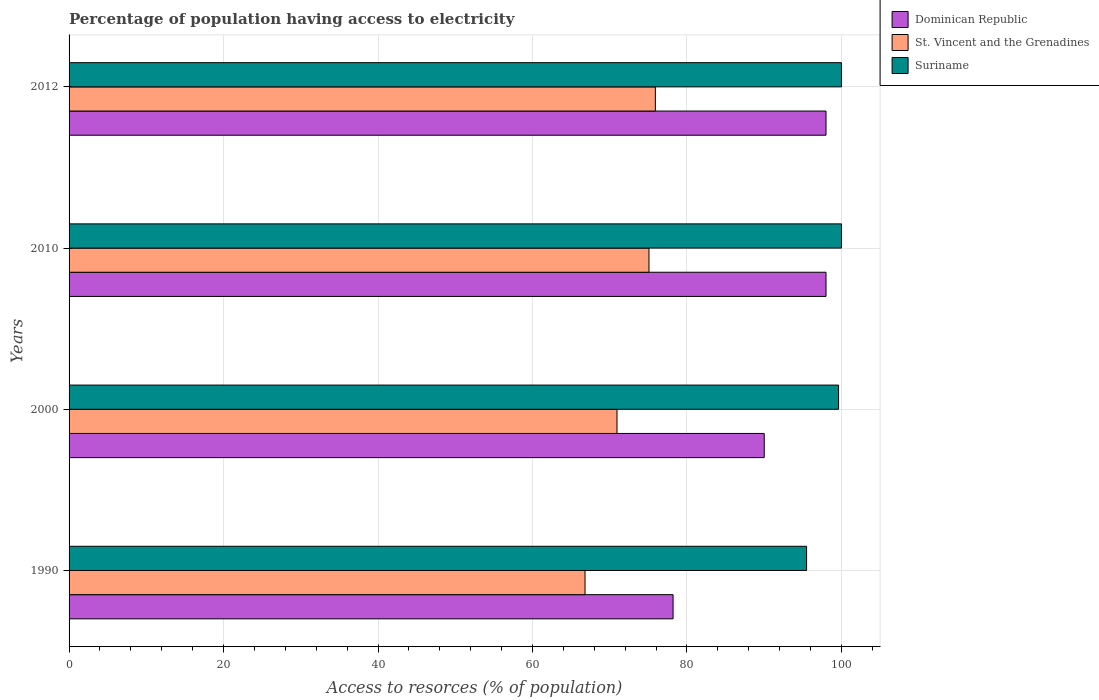How many groups of bars are there?
Provide a succinct answer. 4. How many bars are there on the 4th tick from the bottom?
Provide a short and direct response. 3. What is the percentage of population having access to electricity in St. Vincent and the Grenadines in 2000?
Offer a very short reply. 70.94. Across all years, what is the maximum percentage of population having access to electricity in St. Vincent and the Grenadines?
Ensure brevity in your answer.  75.91. Across all years, what is the minimum percentage of population having access to electricity in Suriname?
Ensure brevity in your answer.  95.49. In which year was the percentage of population having access to electricity in Dominican Republic maximum?
Keep it short and to the point. 2010. In which year was the percentage of population having access to electricity in St. Vincent and the Grenadines minimum?
Provide a short and direct response. 1990. What is the total percentage of population having access to electricity in St. Vincent and the Grenadines in the graph?
Provide a short and direct response. 288.72. What is the difference between the percentage of population having access to electricity in Dominican Republic in 1990 and that in 2010?
Offer a very short reply. -19.8. What is the difference between the percentage of population having access to electricity in Dominican Republic in 2010 and the percentage of population having access to electricity in Suriname in 2000?
Offer a very short reply. -1.62. What is the average percentage of population having access to electricity in Dominican Republic per year?
Your response must be concise. 91.05. In the year 2000, what is the difference between the percentage of population having access to electricity in Suriname and percentage of population having access to electricity in Dominican Republic?
Keep it short and to the point. 9.62. In how many years, is the percentage of population having access to electricity in St. Vincent and the Grenadines greater than 40 %?
Provide a succinct answer. 4. What is the ratio of the percentage of population having access to electricity in Suriname in 1990 to that in 2012?
Your response must be concise. 0.95. Is the percentage of population having access to electricity in St. Vincent and the Grenadines in 1990 less than that in 2012?
Your answer should be compact. Yes. What is the difference between the highest and the second highest percentage of population having access to electricity in St. Vincent and the Grenadines?
Offer a very short reply. 0.83. What is the difference between the highest and the lowest percentage of population having access to electricity in Suriname?
Offer a very short reply. 4.51. In how many years, is the percentage of population having access to electricity in St. Vincent and the Grenadines greater than the average percentage of population having access to electricity in St. Vincent and the Grenadines taken over all years?
Your answer should be compact. 2. Is the sum of the percentage of population having access to electricity in Dominican Republic in 1990 and 2012 greater than the maximum percentage of population having access to electricity in Suriname across all years?
Your answer should be very brief. Yes. What does the 3rd bar from the top in 1990 represents?
Offer a terse response. Dominican Republic. What does the 3rd bar from the bottom in 2012 represents?
Offer a very short reply. Suriname. Are all the bars in the graph horizontal?
Your response must be concise. Yes. What is the difference between two consecutive major ticks on the X-axis?
Provide a short and direct response. 20. Does the graph contain any zero values?
Give a very brief answer. No. What is the title of the graph?
Keep it short and to the point. Percentage of population having access to electricity. Does "Italy" appear as one of the legend labels in the graph?
Your answer should be very brief. No. What is the label or title of the X-axis?
Your response must be concise. Access to resorces (% of population). What is the Access to resorces (% of population) of Dominican Republic in 1990?
Your response must be concise. 78.2. What is the Access to resorces (% of population) of St. Vincent and the Grenadines in 1990?
Make the answer very short. 66.8. What is the Access to resorces (% of population) of Suriname in 1990?
Make the answer very short. 95.49. What is the Access to resorces (% of population) in St. Vincent and the Grenadines in 2000?
Your response must be concise. 70.94. What is the Access to resorces (% of population) in Suriname in 2000?
Ensure brevity in your answer.  99.62. What is the Access to resorces (% of population) in Dominican Republic in 2010?
Your response must be concise. 98. What is the Access to resorces (% of population) of St. Vincent and the Grenadines in 2010?
Provide a succinct answer. 75.08. What is the Access to resorces (% of population) of Suriname in 2010?
Make the answer very short. 100. What is the Access to resorces (% of population) in St. Vincent and the Grenadines in 2012?
Ensure brevity in your answer.  75.91. What is the Access to resorces (% of population) of Suriname in 2012?
Provide a short and direct response. 100. Across all years, what is the maximum Access to resorces (% of population) in Dominican Republic?
Offer a terse response. 98. Across all years, what is the maximum Access to resorces (% of population) of St. Vincent and the Grenadines?
Make the answer very short. 75.91. Across all years, what is the minimum Access to resorces (% of population) of Dominican Republic?
Ensure brevity in your answer.  78.2. Across all years, what is the minimum Access to resorces (% of population) in St. Vincent and the Grenadines?
Your answer should be very brief. 66.8. Across all years, what is the minimum Access to resorces (% of population) in Suriname?
Keep it short and to the point. 95.49. What is the total Access to resorces (% of population) in Dominican Republic in the graph?
Give a very brief answer. 364.2. What is the total Access to resorces (% of population) in St. Vincent and the Grenadines in the graph?
Provide a short and direct response. 288.72. What is the total Access to resorces (% of population) in Suriname in the graph?
Provide a short and direct response. 395.11. What is the difference between the Access to resorces (% of population) in Dominican Republic in 1990 and that in 2000?
Your answer should be very brief. -11.8. What is the difference between the Access to resorces (% of population) in St. Vincent and the Grenadines in 1990 and that in 2000?
Offer a very short reply. -4.14. What is the difference between the Access to resorces (% of population) of Suriname in 1990 and that in 2000?
Keep it short and to the point. -4.14. What is the difference between the Access to resorces (% of population) in Dominican Republic in 1990 and that in 2010?
Offer a very short reply. -19.8. What is the difference between the Access to resorces (% of population) of St. Vincent and the Grenadines in 1990 and that in 2010?
Offer a terse response. -8.28. What is the difference between the Access to resorces (% of population) in Suriname in 1990 and that in 2010?
Give a very brief answer. -4.51. What is the difference between the Access to resorces (% of population) of Dominican Republic in 1990 and that in 2012?
Your answer should be very brief. -19.8. What is the difference between the Access to resorces (% of population) in St. Vincent and the Grenadines in 1990 and that in 2012?
Offer a terse response. -9.11. What is the difference between the Access to resorces (% of population) in Suriname in 1990 and that in 2012?
Offer a very short reply. -4.51. What is the difference between the Access to resorces (% of population) in Dominican Republic in 2000 and that in 2010?
Provide a short and direct response. -8. What is the difference between the Access to resorces (% of population) in St. Vincent and the Grenadines in 2000 and that in 2010?
Your answer should be very brief. -4.14. What is the difference between the Access to resorces (% of population) in Suriname in 2000 and that in 2010?
Provide a short and direct response. -0.38. What is the difference between the Access to resorces (% of population) of St. Vincent and the Grenadines in 2000 and that in 2012?
Provide a short and direct response. -4.97. What is the difference between the Access to resorces (% of population) in Suriname in 2000 and that in 2012?
Give a very brief answer. -0.38. What is the difference between the Access to resorces (% of population) of Dominican Republic in 2010 and that in 2012?
Your response must be concise. 0. What is the difference between the Access to resorces (% of population) of St. Vincent and the Grenadines in 2010 and that in 2012?
Ensure brevity in your answer.  -0.83. What is the difference between the Access to resorces (% of population) of Suriname in 2010 and that in 2012?
Your answer should be very brief. 0. What is the difference between the Access to resorces (% of population) in Dominican Republic in 1990 and the Access to resorces (% of population) in St. Vincent and the Grenadines in 2000?
Provide a succinct answer. 7.26. What is the difference between the Access to resorces (% of population) in Dominican Republic in 1990 and the Access to resorces (% of population) in Suriname in 2000?
Offer a terse response. -21.42. What is the difference between the Access to resorces (% of population) in St. Vincent and the Grenadines in 1990 and the Access to resorces (% of population) in Suriname in 2000?
Offer a terse response. -32.82. What is the difference between the Access to resorces (% of population) of Dominican Republic in 1990 and the Access to resorces (% of population) of St. Vincent and the Grenadines in 2010?
Offer a terse response. 3.12. What is the difference between the Access to resorces (% of population) of Dominican Republic in 1990 and the Access to resorces (% of population) of Suriname in 2010?
Provide a short and direct response. -21.8. What is the difference between the Access to resorces (% of population) of St. Vincent and the Grenadines in 1990 and the Access to resorces (% of population) of Suriname in 2010?
Offer a terse response. -33.2. What is the difference between the Access to resorces (% of population) in Dominican Republic in 1990 and the Access to resorces (% of population) in St. Vincent and the Grenadines in 2012?
Give a very brief answer. 2.29. What is the difference between the Access to resorces (% of population) in Dominican Republic in 1990 and the Access to resorces (% of population) in Suriname in 2012?
Provide a short and direct response. -21.8. What is the difference between the Access to resorces (% of population) in St. Vincent and the Grenadines in 1990 and the Access to resorces (% of population) in Suriname in 2012?
Offer a very short reply. -33.2. What is the difference between the Access to resorces (% of population) of Dominican Republic in 2000 and the Access to resorces (% of population) of St. Vincent and the Grenadines in 2010?
Provide a short and direct response. 14.92. What is the difference between the Access to resorces (% of population) in St. Vincent and the Grenadines in 2000 and the Access to resorces (% of population) in Suriname in 2010?
Your answer should be compact. -29.06. What is the difference between the Access to resorces (% of population) in Dominican Republic in 2000 and the Access to resorces (% of population) in St. Vincent and the Grenadines in 2012?
Provide a short and direct response. 14.09. What is the difference between the Access to resorces (% of population) of St. Vincent and the Grenadines in 2000 and the Access to resorces (% of population) of Suriname in 2012?
Provide a succinct answer. -29.06. What is the difference between the Access to resorces (% of population) of Dominican Republic in 2010 and the Access to resorces (% of population) of St. Vincent and the Grenadines in 2012?
Provide a succinct answer. 22.09. What is the difference between the Access to resorces (% of population) in St. Vincent and the Grenadines in 2010 and the Access to resorces (% of population) in Suriname in 2012?
Keep it short and to the point. -24.92. What is the average Access to resorces (% of population) of Dominican Republic per year?
Provide a short and direct response. 91.05. What is the average Access to resorces (% of population) in St. Vincent and the Grenadines per year?
Ensure brevity in your answer.  72.18. What is the average Access to resorces (% of population) in Suriname per year?
Offer a very short reply. 98.78. In the year 1990, what is the difference between the Access to resorces (% of population) in Dominican Republic and Access to resorces (% of population) in Suriname?
Keep it short and to the point. -17.29. In the year 1990, what is the difference between the Access to resorces (% of population) of St. Vincent and the Grenadines and Access to resorces (% of population) of Suriname?
Offer a very short reply. -28.69. In the year 2000, what is the difference between the Access to resorces (% of population) in Dominican Republic and Access to resorces (% of population) in St. Vincent and the Grenadines?
Your answer should be compact. 19.06. In the year 2000, what is the difference between the Access to resorces (% of population) in Dominican Republic and Access to resorces (% of population) in Suriname?
Make the answer very short. -9.62. In the year 2000, what is the difference between the Access to resorces (% of population) in St. Vincent and the Grenadines and Access to resorces (% of population) in Suriname?
Give a very brief answer. -28.69. In the year 2010, what is the difference between the Access to resorces (% of population) in Dominican Republic and Access to resorces (% of population) in St. Vincent and the Grenadines?
Your answer should be compact. 22.92. In the year 2010, what is the difference between the Access to resorces (% of population) of St. Vincent and the Grenadines and Access to resorces (% of population) of Suriname?
Provide a short and direct response. -24.92. In the year 2012, what is the difference between the Access to resorces (% of population) in Dominican Republic and Access to resorces (% of population) in St. Vincent and the Grenadines?
Give a very brief answer. 22.09. In the year 2012, what is the difference between the Access to resorces (% of population) in Dominican Republic and Access to resorces (% of population) in Suriname?
Ensure brevity in your answer.  -2. In the year 2012, what is the difference between the Access to resorces (% of population) in St. Vincent and the Grenadines and Access to resorces (% of population) in Suriname?
Your answer should be very brief. -24.09. What is the ratio of the Access to resorces (% of population) of Dominican Republic in 1990 to that in 2000?
Your response must be concise. 0.87. What is the ratio of the Access to resorces (% of population) in St. Vincent and the Grenadines in 1990 to that in 2000?
Your response must be concise. 0.94. What is the ratio of the Access to resorces (% of population) in Suriname in 1990 to that in 2000?
Provide a short and direct response. 0.96. What is the ratio of the Access to resorces (% of population) of Dominican Republic in 1990 to that in 2010?
Keep it short and to the point. 0.8. What is the ratio of the Access to resorces (% of population) of St. Vincent and the Grenadines in 1990 to that in 2010?
Make the answer very short. 0.89. What is the ratio of the Access to resorces (% of population) of Suriname in 1990 to that in 2010?
Give a very brief answer. 0.95. What is the ratio of the Access to resorces (% of population) in Dominican Republic in 1990 to that in 2012?
Your answer should be compact. 0.8. What is the ratio of the Access to resorces (% of population) of St. Vincent and the Grenadines in 1990 to that in 2012?
Provide a short and direct response. 0.88. What is the ratio of the Access to resorces (% of population) in Suriname in 1990 to that in 2012?
Give a very brief answer. 0.95. What is the ratio of the Access to resorces (% of population) of Dominican Republic in 2000 to that in 2010?
Provide a succinct answer. 0.92. What is the ratio of the Access to resorces (% of population) in St. Vincent and the Grenadines in 2000 to that in 2010?
Offer a terse response. 0.94. What is the ratio of the Access to resorces (% of population) of Dominican Republic in 2000 to that in 2012?
Ensure brevity in your answer.  0.92. What is the ratio of the Access to resorces (% of population) of St. Vincent and the Grenadines in 2000 to that in 2012?
Make the answer very short. 0.93. What is the ratio of the Access to resorces (% of population) in Dominican Republic in 2010 to that in 2012?
Keep it short and to the point. 1. What is the ratio of the Access to resorces (% of population) in St. Vincent and the Grenadines in 2010 to that in 2012?
Offer a terse response. 0.99. What is the ratio of the Access to resorces (% of population) of Suriname in 2010 to that in 2012?
Make the answer very short. 1. What is the difference between the highest and the second highest Access to resorces (% of population) of Dominican Republic?
Provide a short and direct response. 0. What is the difference between the highest and the second highest Access to resorces (% of population) in St. Vincent and the Grenadines?
Ensure brevity in your answer.  0.83. What is the difference between the highest and the lowest Access to resorces (% of population) in Dominican Republic?
Provide a succinct answer. 19.8. What is the difference between the highest and the lowest Access to resorces (% of population) in St. Vincent and the Grenadines?
Your answer should be compact. 9.11. What is the difference between the highest and the lowest Access to resorces (% of population) in Suriname?
Give a very brief answer. 4.51. 